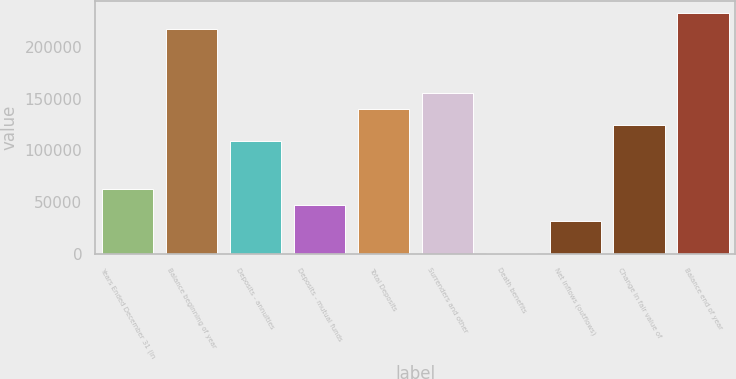Convert chart. <chart><loc_0><loc_0><loc_500><loc_500><bar_chart><fcel>Years Ended December 31 (in<fcel>Balance beginning of year<fcel>Deposits - annuities<fcel>Deposits - mutual funds<fcel>Total Deposits<fcel>Surrenders and other<fcel>Death benefits<fcel>Net inflows (outflows)<fcel>Change in fair value of<fcel>Balance end of year<nl><fcel>62330.6<fcel>217365<fcel>108841<fcel>46827.2<fcel>139848<fcel>155351<fcel>317<fcel>31323.8<fcel>124344<fcel>232868<nl></chart> 